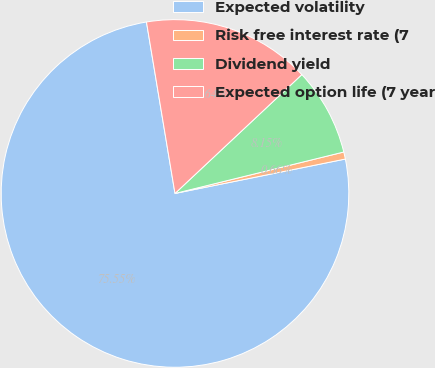Convert chart to OTSL. <chart><loc_0><loc_0><loc_500><loc_500><pie_chart><fcel>Expected volatility<fcel>Risk free interest rate (7<fcel>Dividend yield<fcel>Expected option life (7 year<nl><fcel>75.54%<fcel>0.66%<fcel>8.15%<fcel>15.64%<nl></chart> 